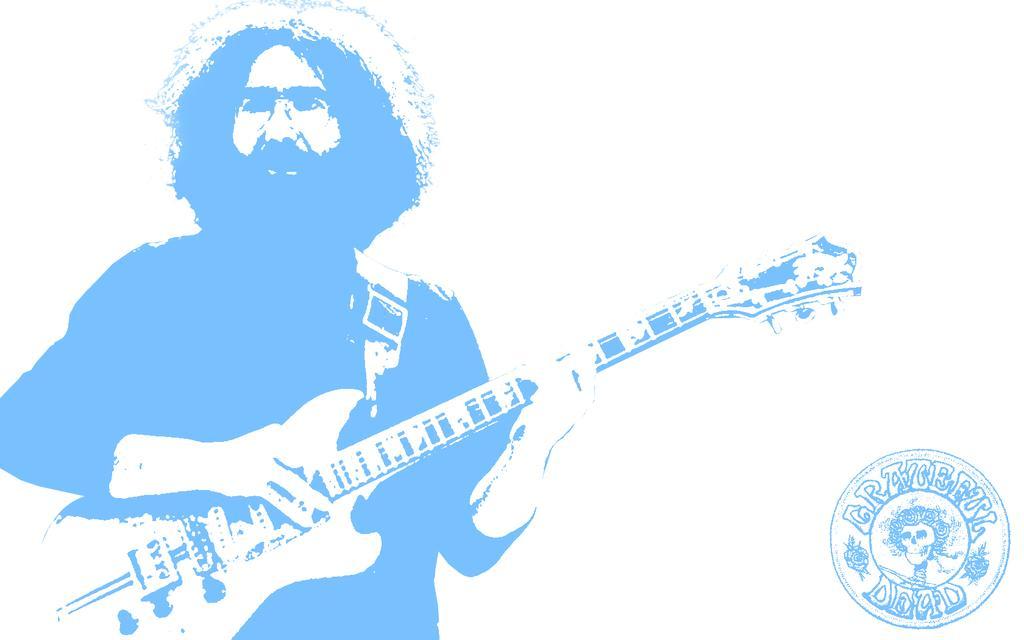Describe this image in one or two sentences. This is an edited image in which we can see a person standing holding a guitar. We can also see a stamp with some text. 